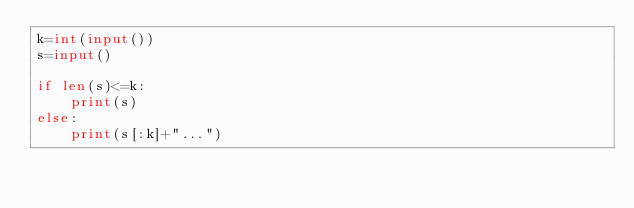Convert code to text. <code><loc_0><loc_0><loc_500><loc_500><_Python_>k=int(input())
s=input()

if len(s)<=k:
    print(s)
else:
    print(s[:k]+"...")</code> 